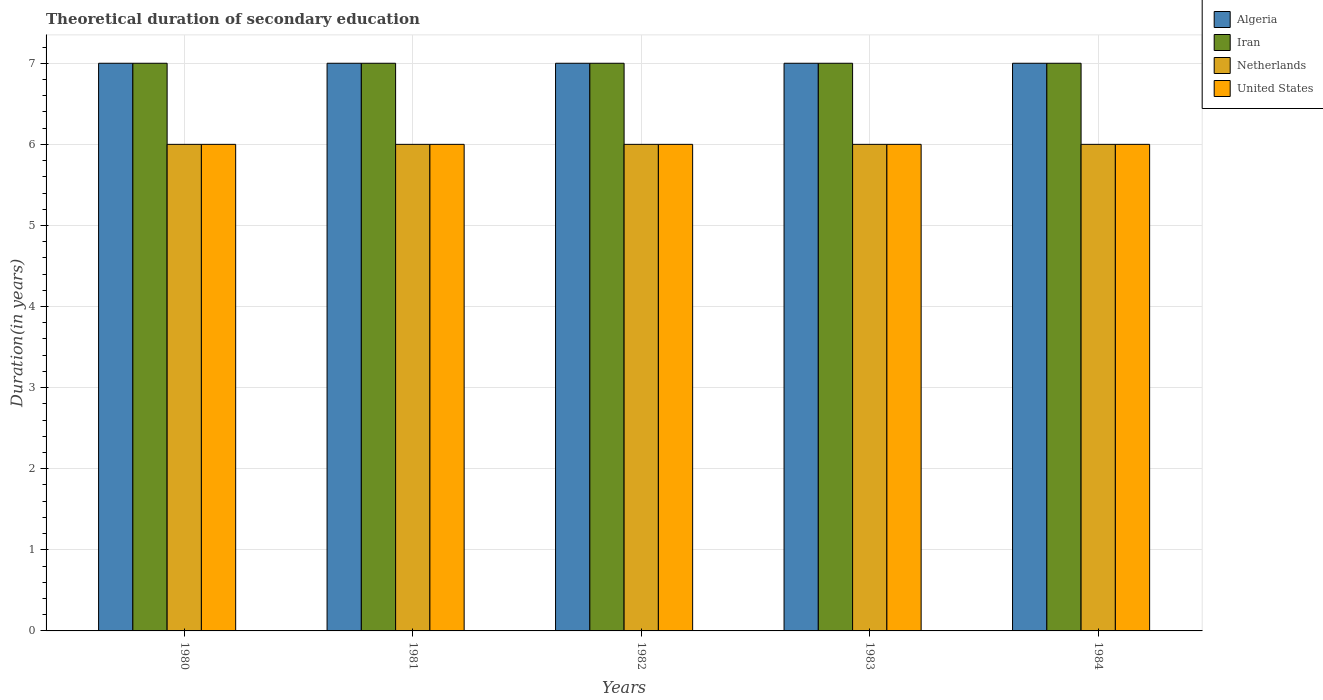How many different coloured bars are there?
Offer a terse response. 4. Are the number of bars per tick equal to the number of legend labels?
Offer a very short reply. Yes. How many bars are there on the 2nd tick from the right?
Offer a very short reply. 4. What is the label of the 3rd group of bars from the left?
Offer a terse response. 1982. Across all years, what is the maximum total theoretical duration of secondary education in Algeria?
Offer a very short reply. 7. Across all years, what is the minimum total theoretical duration of secondary education in Algeria?
Offer a terse response. 7. In which year was the total theoretical duration of secondary education in Iran maximum?
Ensure brevity in your answer.  1980. In which year was the total theoretical duration of secondary education in Algeria minimum?
Make the answer very short. 1980. What is the total total theoretical duration of secondary education in United States in the graph?
Offer a very short reply. 30. What is the difference between the total theoretical duration of secondary education in Iran in 1981 and the total theoretical duration of secondary education in United States in 1984?
Ensure brevity in your answer.  1. In the year 1981, what is the difference between the total theoretical duration of secondary education in Netherlands and total theoretical duration of secondary education in United States?
Provide a short and direct response. 0. In how many years, is the total theoretical duration of secondary education in Iran greater than 0.8 years?
Offer a terse response. 5. What is the difference between the highest and the second highest total theoretical duration of secondary education in United States?
Give a very brief answer. 0. In how many years, is the total theoretical duration of secondary education in Netherlands greater than the average total theoretical duration of secondary education in Netherlands taken over all years?
Offer a very short reply. 0. Is the sum of the total theoretical duration of secondary education in Netherlands in 1982 and 1983 greater than the maximum total theoretical duration of secondary education in Iran across all years?
Offer a terse response. Yes. Is it the case that in every year, the sum of the total theoretical duration of secondary education in United States and total theoretical duration of secondary education in Algeria is greater than the sum of total theoretical duration of secondary education in Netherlands and total theoretical duration of secondary education in Iran?
Offer a terse response. Yes. What does the 3rd bar from the left in 1984 represents?
Offer a very short reply. Netherlands. What does the 4th bar from the right in 1980 represents?
Your answer should be compact. Algeria. How many bars are there?
Make the answer very short. 20. How many years are there in the graph?
Provide a short and direct response. 5. Does the graph contain any zero values?
Keep it short and to the point. No. Does the graph contain grids?
Provide a succinct answer. Yes. How are the legend labels stacked?
Your answer should be compact. Vertical. What is the title of the graph?
Offer a very short reply. Theoretical duration of secondary education. Does "Samoa" appear as one of the legend labels in the graph?
Your answer should be very brief. No. What is the label or title of the X-axis?
Offer a very short reply. Years. What is the label or title of the Y-axis?
Your answer should be very brief. Duration(in years). What is the Duration(in years) of Algeria in 1980?
Provide a short and direct response. 7. What is the Duration(in years) in Iran in 1980?
Provide a short and direct response. 7. What is the Duration(in years) in United States in 1980?
Your answer should be very brief. 6. What is the Duration(in years) in Algeria in 1981?
Provide a short and direct response. 7. What is the Duration(in years) in Iran in 1981?
Provide a succinct answer. 7. What is the Duration(in years) in Netherlands in 1981?
Provide a succinct answer. 6. What is the Duration(in years) of United States in 1981?
Provide a succinct answer. 6. What is the Duration(in years) of Iran in 1982?
Offer a terse response. 7. What is the Duration(in years) in United States in 1982?
Provide a short and direct response. 6. What is the Duration(in years) in Algeria in 1983?
Your answer should be very brief. 7. What is the Duration(in years) of Netherlands in 1983?
Offer a terse response. 6. Across all years, what is the maximum Duration(in years) of Algeria?
Provide a short and direct response. 7. Across all years, what is the maximum Duration(in years) of Netherlands?
Offer a terse response. 6. Across all years, what is the maximum Duration(in years) in United States?
Provide a short and direct response. 6. Across all years, what is the minimum Duration(in years) in Iran?
Your answer should be compact. 7. Across all years, what is the minimum Duration(in years) of United States?
Make the answer very short. 6. What is the total Duration(in years) of Algeria in the graph?
Your answer should be compact. 35. What is the total Duration(in years) of Iran in the graph?
Offer a terse response. 35. What is the total Duration(in years) of United States in the graph?
Your answer should be compact. 30. What is the difference between the Duration(in years) in Iran in 1980 and that in 1981?
Ensure brevity in your answer.  0. What is the difference between the Duration(in years) of Netherlands in 1980 and that in 1981?
Provide a short and direct response. 0. What is the difference between the Duration(in years) of Algeria in 1980 and that in 1982?
Provide a short and direct response. 0. What is the difference between the Duration(in years) of United States in 1980 and that in 1982?
Your answer should be compact. 0. What is the difference between the Duration(in years) of Algeria in 1980 and that in 1983?
Make the answer very short. 0. What is the difference between the Duration(in years) of Iran in 1980 and that in 1983?
Make the answer very short. 0. What is the difference between the Duration(in years) of Netherlands in 1980 and that in 1983?
Offer a terse response. 0. What is the difference between the Duration(in years) in Algeria in 1980 and that in 1984?
Give a very brief answer. 0. What is the difference between the Duration(in years) of Iran in 1980 and that in 1984?
Your answer should be compact. 0. What is the difference between the Duration(in years) in Algeria in 1981 and that in 1982?
Make the answer very short. 0. What is the difference between the Duration(in years) in Iran in 1981 and that in 1982?
Offer a very short reply. 0. What is the difference between the Duration(in years) of Netherlands in 1981 and that in 1982?
Keep it short and to the point. 0. What is the difference between the Duration(in years) in Netherlands in 1981 and that in 1984?
Provide a short and direct response. 0. What is the difference between the Duration(in years) of Algeria in 1982 and that in 1983?
Offer a very short reply. 0. What is the difference between the Duration(in years) in Iran in 1982 and that in 1983?
Make the answer very short. 0. What is the difference between the Duration(in years) in Netherlands in 1982 and that in 1983?
Provide a short and direct response. 0. What is the difference between the Duration(in years) of United States in 1982 and that in 1983?
Provide a succinct answer. 0. What is the difference between the Duration(in years) in Iran in 1982 and that in 1984?
Offer a terse response. 0. What is the difference between the Duration(in years) of Netherlands in 1982 and that in 1984?
Your answer should be very brief. 0. What is the difference between the Duration(in years) of United States in 1982 and that in 1984?
Give a very brief answer. 0. What is the difference between the Duration(in years) of United States in 1983 and that in 1984?
Your answer should be very brief. 0. What is the difference between the Duration(in years) of Algeria in 1980 and the Duration(in years) of United States in 1981?
Offer a very short reply. 1. What is the difference between the Duration(in years) in Netherlands in 1980 and the Duration(in years) in United States in 1981?
Offer a very short reply. 0. What is the difference between the Duration(in years) of Algeria in 1980 and the Duration(in years) of Iran in 1982?
Your answer should be compact. 0. What is the difference between the Duration(in years) of Algeria in 1980 and the Duration(in years) of Iran in 1984?
Your answer should be very brief. 0. What is the difference between the Duration(in years) in Iran in 1980 and the Duration(in years) in United States in 1984?
Your answer should be very brief. 1. What is the difference between the Duration(in years) of Algeria in 1981 and the Duration(in years) of Netherlands in 1982?
Your answer should be compact. 1. What is the difference between the Duration(in years) of Algeria in 1981 and the Duration(in years) of United States in 1982?
Your answer should be compact. 1. What is the difference between the Duration(in years) in Iran in 1981 and the Duration(in years) in Netherlands in 1982?
Offer a terse response. 1. What is the difference between the Duration(in years) in Iran in 1981 and the Duration(in years) in United States in 1982?
Provide a succinct answer. 1. What is the difference between the Duration(in years) of Algeria in 1981 and the Duration(in years) of Iran in 1983?
Give a very brief answer. 0. What is the difference between the Duration(in years) in Iran in 1981 and the Duration(in years) in Netherlands in 1983?
Your answer should be very brief. 1. What is the difference between the Duration(in years) in Iran in 1981 and the Duration(in years) in United States in 1983?
Make the answer very short. 1. What is the difference between the Duration(in years) of Netherlands in 1981 and the Duration(in years) of United States in 1983?
Offer a very short reply. 0. What is the difference between the Duration(in years) in Algeria in 1981 and the Duration(in years) in Netherlands in 1984?
Provide a short and direct response. 1. What is the difference between the Duration(in years) of Algeria in 1982 and the Duration(in years) of Iran in 1983?
Provide a short and direct response. 0. What is the difference between the Duration(in years) in Iran in 1982 and the Duration(in years) in United States in 1983?
Offer a terse response. 1. What is the difference between the Duration(in years) in Netherlands in 1982 and the Duration(in years) in United States in 1983?
Ensure brevity in your answer.  0. What is the difference between the Duration(in years) of Algeria in 1982 and the Duration(in years) of Iran in 1984?
Give a very brief answer. 0. What is the difference between the Duration(in years) of Netherlands in 1982 and the Duration(in years) of United States in 1984?
Your response must be concise. 0. What is the difference between the Duration(in years) of Algeria in 1983 and the Duration(in years) of United States in 1984?
Provide a short and direct response. 1. What is the difference between the Duration(in years) in Iran in 1983 and the Duration(in years) in United States in 1984?
Your answer should be compact. 1. What is the difference between the Duration(in years) of Netherlands in 1983 and the Duration(in years) of United States in 1984?
Your response must be concise. 0. What is the average Duration(in years) of Algeria per year?
Your answer should be very brief. 7. What is the average Duration(in years) in Netherlands per year?
Provide a short and direct response. 6. In the year 1980, what is the difference between the Duration(in years) of Algeria and Duration(in years) of Netherlands?
Ensure brevity in your answer.  1. In the year 1980, what is the difference between the Duration(in years) in Algeria and Duration(in years) in United States?
Offer a very short reply. 1. In the year 1980, what is the difference between the Duration(in years) of Iran and Duration(in years) of United States?
Your answer should be very brief. 1. In the year 1980, what is the difference between the Duration(in years) in Netherlands and Duration(in years) in United States?
Ensure brevity in your answer.  0. In the year 1981, what is the difference between the Duration(in years) of Iran and Duration(in years) of Netherlands?
Give a very brief answer. 1. In the year 1981, what is the difference between the Duration(in years) in Iran and Duration(in years) in United States?
Your answer should be very brief. 1. In the year 1981, what is the difference between the Duration(in years) of Netherlands and Duration(in years) of United States?
Ensure brevity in your answer.  0. In the year 1982, what is the difference between the Duration(in years) in Algeria and Duration(in years) in Iran?
Your answer should be very brief. 0. In the year 1982, what is the difference between the Duration(in years) in Algeria and Duration(in years) in United States?
Ensure brevity in your answer.  1. In the year 1982, what is the difference between the Duration(in years) of Iran and Duration(in years) of United States?
Your answer should be compact. 1. In the year 1983, what is the difference between the Duration(in years) in Iran and Duration(in years) in United States?
Keep it short and to the point. 1. In the year 1983, what is the difference between the Duration(in years) of Netherlands and Duration(in years) of United States?
Ensure brevity in your answer.  0. What is the ratio of the Duration(in years) in Algeria in 1980 to that in 1982?
Your answer should be compact. 1. What is the ratio of the Duration(in years) in Iran in 1980 to that in 1982?
Your response must be concise. 1. What is the ratio of the Duration(in years) in Iran in 1980 to that in 1983?
Your answer should be compact. 1. What is the ratio of the Duration(in years) in Netherlands in 1980 to that in 1983?
Give a very brief answer. 1. What is the ratio of the Duration(in years) of United States in 1980 to that in 1983?
Your response must be concise. 1. What is the ratio of the Duration(in years) in Iran in 1980 to that in 1984?
Provide a short and direct response. 1. What is the ratio of the Duration(in years) of United States in 1980 to that in 1984?
Your response must be concise. 1. What is the ratio of the Duration(in years) in Algeria in 1981 to that in 1983?
Offer a very short reply. 1. What is the ratio of the Duration(in years) of Iran in 1981 to that in 1983?
Make the answer very short. 1. What is the ratio of the Duration(in years) in United States in 1981 to that in 1983?
Your response must be concise. 1. What is the ratio of the Duration(in years) of Algeria in 1981 to that in 1984?
Provide a short and direct response. 1. What is the ratio of the Duration(in years) of Iran in 1981 to that in 1984?
Make the answer very short. 1. What is the ratio of the Duration(in years) of United States in 1981 to that in 1984?
Provide a short and direct response. 1. What is the ratio of the Duration(in years) in Algeria in 1982 to that in 1983?
Provide a short and direct response. 1. What is the ratio of the Duration(in years) of Iran in 1982 to that in 1983?
Give a very brief answer. 1. What is the ratio of the Duration(in years) of Netherlands in 1982 to that in 1983?
Offer a terse response. 1. What is the ratio of the Duration(in years) in Netherlands in 1982 to that in 1984?
Provide a succinct answer. 1. What is the difference between the highest and the second highest Duration(in years) in Algeria?
Give a very brief answer. 0. What is the difference between the highest and the second highest Duration(in years) in Iran?
Give a very brief answer. 0. What is the difference between the highest and the second highest Duration(in years) of Netherlands?
Your answer should be very brief. 0. What is the difference between the highest and the second highest Duration(in years) in United States?
Offer a terse response. 0. What is the difference between the highest and the lowest Duration(in years) in Algeria?
Your response must be concise. 0. What is the difference between the highest and the lowest Duration(in years) in Iran?
Provide a short and direct response. 0. What is the difference between the highest and the lowest Duration(in years) in Netherlands?
Your answer should be compact. 0. What is the difference between the highest and the lowest Duration(in years) in United States?
Offer a very short reply. 0. 